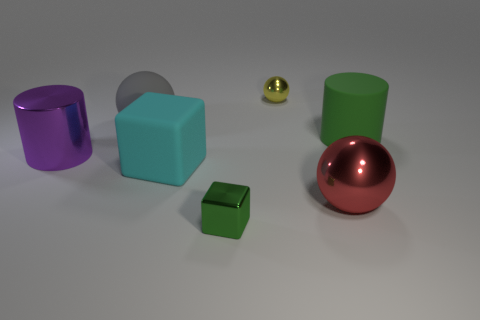Is the number of large rubber objects that are right of the small ball greater than the number of small gray cubes?
Ensure brevity in your answer.  Yes. There is a large metal thing to the right of the small metal thing in front of the cyan matte object; what number of big green rubber things are in front of it?
Ensure brevity in your answer.  0. There is a metallic object that is to the left of the big rubber cube; does it have the same size as the metallic ball that is behind the big purple shiny cylinder?
Offer a very short reply. No. There is a large object behind the cylinder right of the big gray ball; what is it made of?
Ensure brevity in your answer.  Rubber. How many objects are either large matte objects that are to the left of the yellow ball or large green cylinders?
Provide a succinct answer. 3. Are there the same number of big green cylinders on the left side of the big cyan rubber cube and large red metallic spheres behind the red ball?
Your response must be concise. Yes. The block in front of the big metal object that is on the right side of the metal sphere that is behind the purple cylinder is made of what material?
Your answer should be compact. Metal. What is the size of the sphere that is to the right of the large cyan matte block and behind the large metallic sphere?
Keep it short and to the point. Small. Do the large green thing and the yellow metallic object have the same shape?
Offer a very short reply. No. There is a large red object that is made of the same material as the small green cube; what shape is it?
Your answer should be compact. Sphere. 